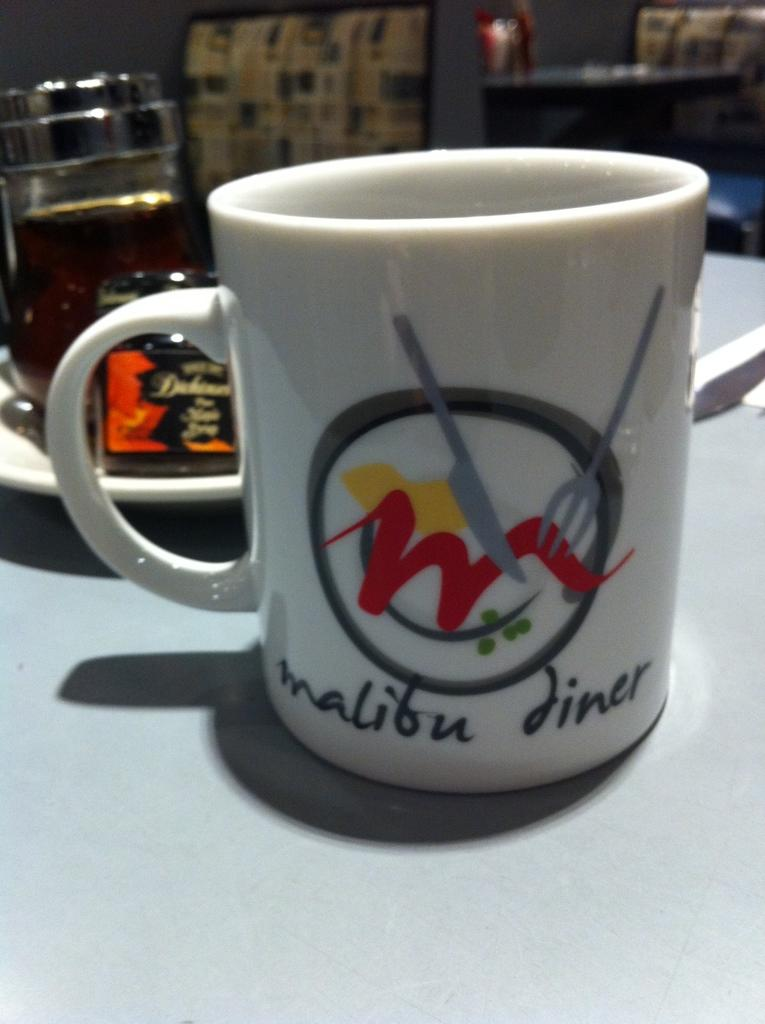<image>
Describe the image concisely. Coffee mug sitting on a table in a restaurant with the name of the establishment and their logo on the mug. 